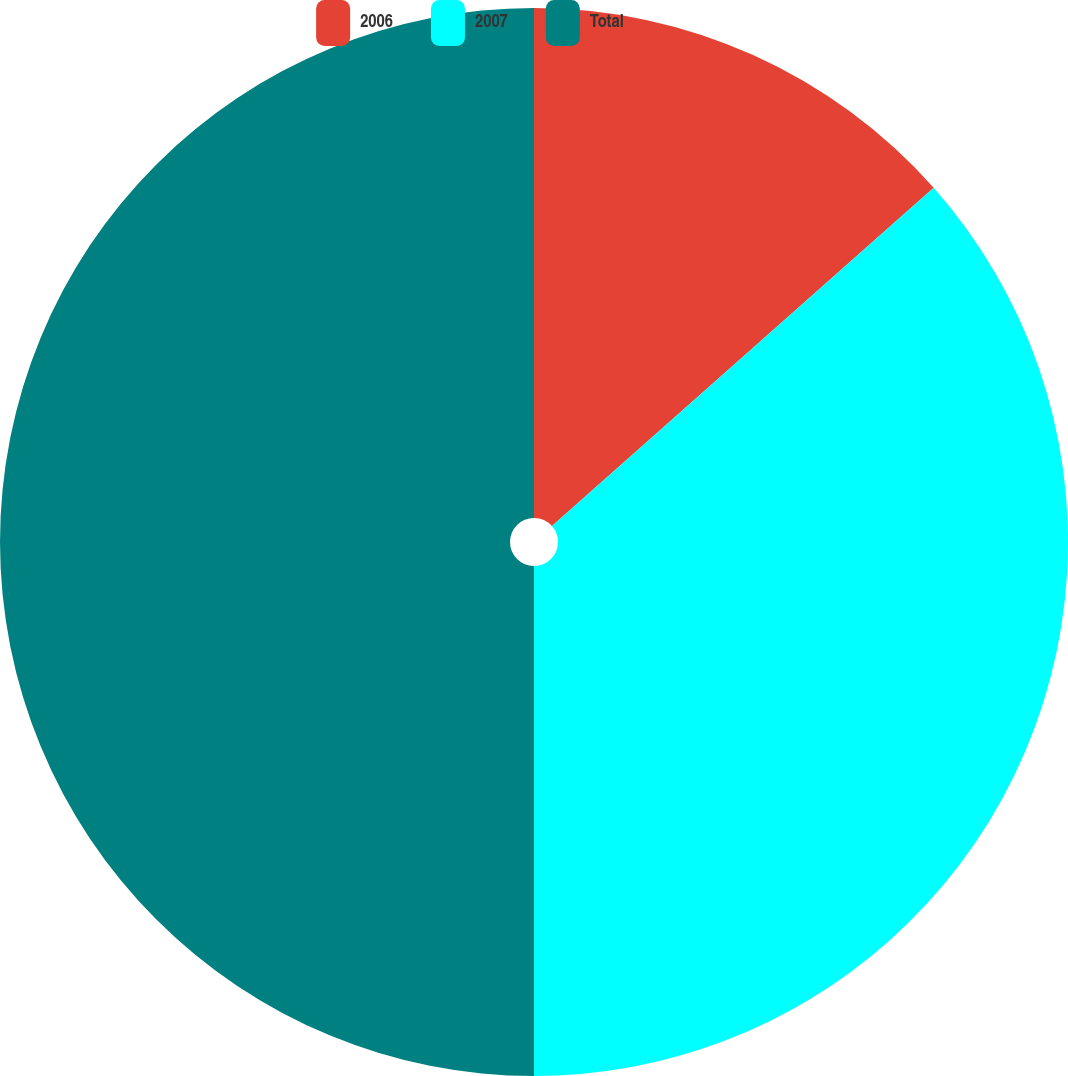Convert chart to OTSL. <chart><loc_0><loc_0><loc_500><loc_500><pie_chart><fcel>2006<fcel>2007<fcel>Total<nl><fcel>13.46%<fcel>36.54%<fcel>50.0%<nl></chart> 